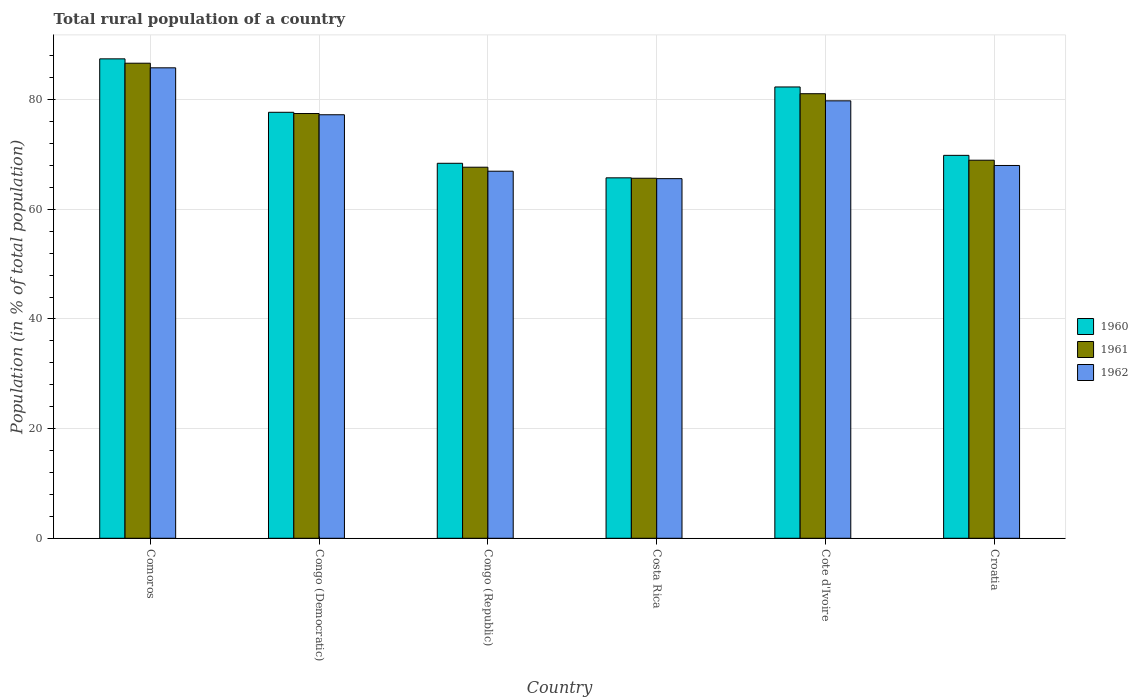How many groups of bars are there?
Offer a very short reply. 6. How many bars are there on the 5th tick from the right?
Provide a succinct answer. 3. What is the label of the 3rd group of bars from the left?
Your response must be concise. Congo (Republic). What is the rural population in 1960 in Costa Rica?
Provide a short and direct response. 65.75. Across all countries, what is the maximum rural population in 1961?
Keep it short and to the point. 86.65. Across all countries, what is the minimum rural population in 1961?
Your answer should be compact. 65.67. In which country was the rural population in 1962 maximum?
Your answer should be compact. Comoros. What is the total rural population in 1961 in the graph?
Keep it short and to the point. 447.53. What is the difference between the rural population in 1962 in Congo (Democratic) and that in Costa Rica?
Give a very brief answer. 11.66. What is the difference between the rural population in 1962 in Congo (Republic) and the rural population in 1961 in Cote d'Ivoire?
Ensure brevity in your answer.  -14.13. What is the average rural population in 1962 per country?
Offer a terse response. 73.9. What is the difference between the rural population of/in 1961 and rural population of/in 1960 in Comoros?
Your answer should be compact. -0.8. What is the ratio of the rural population in 1960 in Congo (Democratic) to that in Congo (Republic)?
Provide a succinct answer. 1.14. Is the rural population in 1961 in Congo (Republic) less than that in Croatia?
Provide a succinct answer. Yes. What is the difference between the highest and the second highest rural population in 1962?
Give a very brief answer. -8.56. What is the difference between the highest and the lowest rural population in 1960?
Your response must be concise. 21.7. Is the sum of the rural population in 1961 in Comoros and Croatia greater than the maximum rural population in 1962 across all countries?
Make the answer very short. Yes. What does the 1st bar from the left in Croatia represents?
Provide a succinct answer. 1960. What does the 2nd bar from the right in Congo (Republic) represents?
Your answer should be compact. 1961. Is it the case that in every country, the sum of the rural population in 1960 and rural population in 1962 is greater than the rural population in 1961?
Ensure brevity in your answer.  Yes. How many bars are there?
Your answer should be very brief. 18. Are all the bars in the graph horizontal?
Offer a terse response. No. How are the legend labels stacked?
Offer a terse response. Vertical. What is the title of the graph?
Give a very brief answer. Total rural population of a country. What is the label or title of the X-axis?
Your response must be concise. Country. What is the label or title of the Y-axis?
Ensure brevity in your answer.  Population (in % of total population). What is the Population (in % of total population) of 1960 in Comoros?
Your response must be concise. 87.45. What is the Population (in % of total population) of 1961 in Comoros?
Provide a short and direct response. 86.65. What is the Population (in % of total population) in 1962 in Comoros?
Your answer should be very brief. 85.81. What is the Population (in % of total population) in 1960 in Congo (Democratic)?
Make the answer very short. 77.7. What is the Population (in % of total population) in 1961 in Congo (Democratic)?
Provide a short and direct response. 77.48. What is the Population (in % of total population) of 1962 in Congo (Democratic)?
Offer a very short reply. 77.25. What is the Population (in % of total population) of 1960 in Congo (Republic)?
Make the answer very short. 68.4. What is the Population (in % of total population) in 1961 in Congo (Republic)?
Your answer should be compact. 67.68. What is the Population (in % of total population) of 1962 in Congo (Republic)?
Offer a terse response. 66.95. What is the Population (in % of total population) of 1960 in Costa Rica?
Offer a very short reply. 65.75. What is the Population (in % of total population) of 1961 in Costa Rica?
Your response must be concise. 65.67. What is the Population (in % of total population) of 1962 in Costa Rica?
Give a very brief answer. 65.6. What is the Population (in % of total population) in 1960 in Cote d'Ivoire?
Offer a very short reply. 82.32. What is the Population (in % of total population) in 1961 in Cote d'Ivoire?
Keep it short and to the point. 81.09. What is the Population (in % of total population) of 1962 in Cote d'Ivoire?
Your answer should be compact. 79.79. What is the Population (in % of total population) in 1960 in Croatia?
Ensure brevity in your answer.  69.85. What is the Population (in % of total population) in 1961 in Croatia?
Provide a short and direct response. 68.96. What is the Population (in % of total population) in 1962 in Croatia?
Your response must be concise. 68. Across all countries, what is the maximum Population (in % of total population) of 1960?
Ensure brevity in your answer.  87.45. Across all countries, what is the maximum Population (in % of total population) in 1961?
Offer a terse response. 86.65. Across all countries, what is the maximum Population (in % of total population) of 1962?
Keep it short and to the point. 85.81. Across all countries, what is the minimum Population (in % of total population) in 1960?
Provide a short and direct response. 65.75. Across all countries, what is the minimum Population (in % of total population) in 1961?
Provide a short and direct response. 65.67. Across all countries, what is the minimum Population (in % of total population) of 1962?
Offer a very short reply. 65.6. What is the total Population (in % of total population) of 1960 in the graph?
Provide a succinct answer. 451.46. What is the total Population (in % of total population) in 1961 in the graph?
Your answer should be very brief. 447.53. What is the total Population (in % of total population) of 1962 in the graph?
Provide a short and direct response. 443.4. What is the difference between the Population (in % of total population) of 1960 in Comoros and that in Congo (Democratic)?
Ensure brevity in your answer.  9.75. What is the difference between the Population (in % of total population) of 1961 in Comoros and that in Congo (Democratic)?
Your answer should be very brief. 9.18. What is the difference between the Population (in % of total population) of 1962 in Comoros and that in Congo (Democratic)?
Your answer should be very brief. 8.56. What is the difference between the Population (in % of total population) of 1960 in Comoros and that in Congo (Republic)?
Your answer should be compact. 19.05. What is the difference between the Population (in % of total population) in 1961 in Comoros and that in Congo (Republic)?
Offer a very short reply. 18.97. What is the difference between the Population (in % of total population) of 1962 in Comoros and that in Congo (Republic)?
Your answer should be compact. 18.86. What is the difference between the Population (in % of total population) of 1960 in Comoros and that in Costa Rica?
Give a very brief answer. 21.7. What is the difference between the Population (in % of total population) in 1961 in Comoros and that in Costa Rica?
Your answer should be very brief. 20.98. What is the difference between the Population (in % of total population) of 1962 in Comoros and that in Costa Rica?
Keep it short and to the point. 20.21. What is the difference between the Population (in % of total population) in 1960 in Comoros and that in Cote d'Ivoire?
Give a very brief answer. 5.13. What is the difference between the Population (in % of total population) of 1961 in Comoros and that in Cote d'Ivoire?
Keep it short and to the point. 5.56. What is the difference between the Population (in % of total population) of 1962 in Comoros and that in Cote d'Ivoire?
Give a very brief answer. 6.02. What is the difference between the Population (in % of total population) of 1960 in Comoros and that in Croatia?
Your answer should be very brief. 17.6. What is the difference between the Population (in % of total population) in 1961 in Comoros and that in Croatia?
Ensure brevity in your answer.  17.69. What is the difference between the Population (in % of total population) of 1962 in Comoros and that in Croatia?
Provide a short and direct response. 17.81. What is the difference between the Population (in % of total population) in 1960 in Congo (Democratic) and that in Congo (Republic)?
Your response must be concise. 9.3. What is the difference between the Population (in % of total population) in 1961 in Congo (Democratic) and that in Congo (Republic)?
Provide a succinct answer. 9.79. What is the difference between the Population (in % of total population) of 1962 in Congo (Democratic) and that in Congo (Republic)?
Your answer should be compact. 10.3. What is the difference between the Population (in % of total population) of 1960 in Congo (Democratic) and that in Costa Rica?
Keep it short and to the point. 11.95. What is the difference between the Population (in % of total population) in 1961 in Congo (Democratic) and that in Costa Rica?
Offer a very short reply. 11.81. What is the difference between the Population (in % of total population) of 1962 in Congo (Democratic) and that in Costa Rica?
Provide a short and direct response. 11.65. What is the difference between the Population (in % of total population) of 1960 in Congo (Democratic) and that in Cote d'Ivoire?
Make the answer very short. -4.62. What is the difference between the Population (in % of total population) of 1961 in Congo (Democratic) and that in Cote d'Ivoire?
Your answer should be very brief. -3.61. What is the difference between the Population (in % of total population) of 1962 in Congo (Democratic) and that in Cote d'Ivoire?
Provide a succinct answer. -2.54. What is the difference between the Population (in % of total population) of 1960 in Congo (Democratic) and that in Croatia?
Provide a short and direct response. 7.85. What is the difference between the Population (in % of total population) of 1961 in Congo (Democratic) and that in Croatia?
Provide a short and direct response. 8.52. What is the difference between the Population (in % of total population) of 1962 in Congo (Democratic) and that in Croatia?
Your response must be concise. 9.25. What is the difference between the Population (in % of total population) in 1960 in Congo (Republic) and that in Costa Rica?
Your answer should be very brief. 2.65. What is the difference between the Population (in % of total population) in 1961 in Congo (Republic) and that in Costa Rica?
Offer a very short reply. 2.01. What is the difference between the Population (in % of total population) in 1962 in Congo (Republic) and that in Costa Rica?
Keep it short and to the point. 1.36. What is the difference between the Population (in % of total population) of 1960 in Congo (Republic) and that in Cote d'Ivoire?
Keep it short and to the point. -13.92. What is the difference between the Population (in % of total population) of 1961 in Congo (Republic) and that in Cote d'Ivoire?
Keep it short and to the point. -13.41. What is the difference between the Population (in % of total population) in 1962 in Congo (Republic) and that in Cote d'Ivoire?
Keep it short and to the point. -12.84. What is the difference between the Population (in % of total population) of 1960 in Congo (Republic) and that in Croatia?
Ensure brevity in your answer.  -1.45. What is the difference between the Population (in % of total population) of 1961 in Congo (Republic) and that in Croatia?
Your answer should be compact. -1.28. What is the difference between the Population (in % of total population) of 1962 in Congo (Republic) and that in Croatia?
Your answer should be compact. -1.04. What is the difference between the Population (in % of total population) of 1960 in Costa Rica and that in Cote d'Ivoire?
Keep it short and to the point. -16.57. What is the difference between the Population (in % of total population) of 1961 in Costa Rica and that in Cote d'Ivoire?
Keep it short and to the point. -15.42. What is the difference between the Population (in % of total population) of 1962 in Costa Rica and that in Cote d'Ivoire?
Offer a terse response. -14.19. What is the difference between the Population (in % of total population) of 1961 in Costa Rica and that in Croatia?
Offer a very short reply. -3.29. What is the difference between the Population (in % of total population) in 1962 in Costa Rica and that in Croatia?
Offer a terse response. -2.4. What is the difference between the Population (in % of total population) in 1960 in Cote d'Ivoire and that in Croatia?
Offer a terse response. 12.47. What is the difference between the Population (in % of total population) in 1961 in Cote d'Ivoire and that in Croatia?
Your response must be concise. 12.13. What is the difference between the Population (in % of total population) in 1962 in Cote d'Ivoire and that in Croatia?
Ensure brevity in your answer.  11.79. What is the difference between the Population (in % of total population) of 1960 in Comoros and the Population (in % of total population) of 1961 in Congo (Democratic)?
Keep it short and to the point. 9.97. What is the difference between the Population (in % of total population) of 1960 in Comoros and the Population (in % of total population) of 1962 in Congo (Democratic)?
Your answer should be compact. 10.2. What is the difference between the Population (in % of total population) of 1961 in Comoros and the Population (in % of total population) of 1962 in Congo (Democratic)?
Your answer should be very brief. 9.4. What is the difference between the Population (in % of total population) in 1960 in Comoros and the Population (in % of total population) in 1961 in Congo (Republic)?
Keep it short and to the point. 19.77. What is the difference between the Population (in % of total population) in 1960 in Comoros and the Population (in % of total population) in 1962 in Congo (Republic)?
Provide a short and direct response. 20.49. What is the difference between the Population (in % of total population) of 1961 in Comoros and the Population (in % of total population) of 1962 in Congo (Republic)?
Your answer should be compact. 19.7. What is the difference between the Population (in % of total population) in 1960 in Comoros and the Population (in % of total population) in 1961 in Costa Rica?
Make the answer very short. 21.78. What is the difference between the Population (in % of total population) of 1960 in Comoros and the Population (in % of total population) of 1962 in Costa Rica?
Make the answer very short. 21.85. What is the difference between the Population (in % of total population) in 1961 in Comoros and the Population (in % of total population) in 1962 in Costa Rica?
Make the answer very short. 21.06. What is the difference between the Population (in % of total population) in 1960 in Comoros and the Population (in % of total population) in 1961 in Cote d'Ivoire?
Make the answer very short. 6.36. What is the difference between the Population (in % of total population) of 1960 in Comoros and the Population (in % of total population) of 1962 in Cote d'Ivoire?
Your response must be concise. 7.66. What is the difference between the Population (in % of total population) in 1961 in Comoros and the Population (in % of total population) in 1962 in Cote d'Ivoire?
Make the answer very short. 6.86. What is the difference between the Population (in % of total population) of 1960 in Comoros and the Population (in % of total population) of 1961 in Croatia?
Give a very brief answer. 18.49. What is the difference between the Population (in % of total population) in 1960 in Comoros and the Population (in % of total population) in 1962 in Croatia?
Give a very brief answer. 19.45. What is the difference between the Population (in % of total population) in 1961 in Comoros and the Population (in % of total population) in 1962 in Croatia?
Give a very brief answer. 18.65. What is the difference between the Population (in % of total population) in 1960 in Congo (Democratic) and the Population (in % of total population) in 1961 in Congo (Republic)?
Provide a short and direct response. 10.02. What is the difference between the Population (in % of total population) of 1960 in Congo (Democratic) and the Population (in % of total population) of 1962 in Congo (Republic)?
Your answer should be very brief. 10.74. What is the difference between the Population (in % of total population) of 1961 in Congo (Democratic) and the Population (in % of total population) of 1962 in Congo (Republic)?
Offer a terse response. 10.52. What is the difference between the Population (in % of total population) in 1960 in Congo (Democratic) and the Population (in % of total population) in 1961 in Costa Rica?
Provide a succinct answer. 12.03. What is the difference between the Population (in % of total population) of 1960 in Congo (Democratic) and the Population (in % of total population) of 1962 in Costa Rica?
Your response must be concise. 12.1. What is the difference between the Population (in % of total population) in 1961 in Congo (Democratic) and the Population (in % of total population) in 1962 in Costa Rica?
Your answer should be compact. 11.88. What is the difference between the Population (in % of total population) of 1960 in Congo (Democratic) and the Population (in % of total population) of 1961 in Cote d'Ivoire?
Provide a succinct answer. -3.39. What is the difference between the Population (in % of total population) of 1960 in Congo (Democratic) and the Population (in % of total population) of 1962 in Cote d'Ivoire?
Ensure brevity in your answer.  -2.09. What is the difference between the Population (in % of total population) in 1961 in Congo (Democratic) and the Population (in % of total population) in 1962 in Cote d'Ivoire?
Your response must be concise. -2.31. What is the difference between the Population (in % of total population) in 1960 in Congo (Democratic) and the Population (in % of total population) in 1961 in Croatia?
Provide a succinct answer. 8.74. What is the difference between the Population (in % of total population) of 1960 in Congo (Democratic) and the Population (in % of total population) of 1962 in Croatia?
Offer a very short reply. 9.7. What is the difference between the Population (in % of total population) in 1961 in Congo (Democratic) and the Population (in % of total population) in 1962 in Croatia?
Offer a very short reply. 9.48. What is the difference between the Population (in % of total population) of 1960 in Congo (Republic) and the Population (in % of total population) of 1961 in Costa Rica?
Make the answer very short. 2.73. What is the difference between the Population (in % of total population) of 1960 in Congo (Republic) and the Population (in % of total population) of 1962 in Costa Rica?
Your response must be concise. 2.8. What is the difference between the Population (in % of total population) of 1961 in Congo (Republic) and the Population (in % of total population) of 1962 in Costa Rica?
Offer a very short reply. 2.09. What is the difference between the Population (in % of total population) in 1960 in Congo (Republic) and the Population (in % of total population) in 1961 in Cote d'Ivoire?
Give a very brief answer. -12.69. What is the difference between the Population (in % of total population) in 1960 in Congo (Republic) and the Population (in % of total population) in 1962 in Cote d'Ivoire?
Provide a succinct answer. -11.39. What is the difference between the Population (in % of total population) in 1961 in Congo (Republic) and the Population (in % of total population) in 1962 in Cote d'Ivoire?
Your answer should be very brief. -12.11. What is the difference between the Population (in % of total population) in 1960 in Congo (Republic) and the Population (in % of total population) in 1961 in Croatia?
Give a very brief answer. -0.56. What is the difference between the Population (in % of total population) of 1961 in Congo (Republic) and the Population (in % of total population) of 1962 in Croatia?
Ensure brevity in your answer.  -0.32. What is the difference between the Population (in % of total population) in 1960 in Costa Rica and the Population (in % of total population) in 1961 in Cote d'Ivoire?
Offer a very short reply. -15.34. What is the difference between the Population (in % of total population) in 1960 in Costa Rica and the Population (in % of total population) in 1962 in Cote d'Ivoire?
Your answer should be compact. -14.04. What is the difference between the Population (in % of total population) of 1961 in Costa Rica and the Population (in % of total population) of 1962 in Cote d'Ivoire?
Your response must be concise. -14.12. What is the difference between the Population (in % of total population) in 1960 in Costa Rica and the Population (in % of total population) in 1961 in Croatia?
Your answer should be very brief. -3.21. What is the difference between the Population (in % of total population) in 1960 in Costa Rica and the Population (in % of total population) in 1962 in Croatia?
Your answer should be very brief. -2.25. What is the difference between the Population (in % of total population) in 1961 in Costa Rica and the Population (in % of total population) in 1962 in Croatia?
Your answer should be very brief. -2.33. What is the difference between the Population (in % of total population) of 1960 in Cote d'Ivoire and the Population (in % of total population) of 1961 in Croatia?
Make the answer very short. 13.36. What is the difference between the Population (in % of total population) in 1960 in Cote d'Ivoire and the Population (in % of total population) in 1962 in Croatia?
Give a very brief answer. 14.32. What is the difference between the Population (in % of total population) in 1961 in Cote d'Ivoire and the Population (in % of total population) in 1962 in Croatia?
Ensure brevity in your answer.  13.09. What is the average Population (in % of total population) in 1960 per country?
Offer a terse response. 75.24. What is the average Population (in % of total population) of 1961 per country?
Offer a very short reply. 74.59. What is the average Population (in % of total population) in 1962 per country?
Your answer should be very brief. 73.9. What is the difference between the Population (in % of total population) of 1960 and Population (in % of total population) of 1961 in Comoros?
Give a very brief answer. 0.8. What is the difference between the Population (in % of total population) in 1960 and Population (in % of total population) in 1962 in Comoros?
Provide a short and direct response. 1.64. What is the difference between the Population (in % of total population) of 1961 and Population (in % of total population) of 1962 in Comoros?
Your response must be concise. 0.84. What is the difference between the Population (in % of total population) of 1960 and Population (in % of total population) of 1961 in Congo (Democratic)?
Your answer should be very brief. 0.22. What is the difference between the Population (in % of total population) of 1960 and Population (in % of total population) of 1962 in Congo (Democratic)?
Offer a terse response. 0.45. What is the difference between the Population (in % of total population) of 1961 and Population (in % of total population) of 1962 in Congo (Democratic)?
Provide a succinct answer. 0.23. What is the difference between the Population (in % of total population) of 1960 and Population (in % of total population) of 1961 in Congo (Republic)?
Your response must be concise. 0.72. What is the difference between the Population (in % of total population) of 1960 and Population (in % of total population) of 1962 in Congo (Republic)?
Offer a terse response. 1.44. What is the difference between the Population (in % of total population) in 1961 and Population (in % of total population) in 1962 in Congo (Republic)?
Your answer should be very brief. 0.73. What is the difference between the Population (in % of total population) in 1960 and Population (in % of total population) in 1961 in Costa Rica?
Your answer should be very brief. 0.07. What is the difference between the Population (in % of total population) of 1960 and Population (in % of total population) of 1962 in Costa Rica?
Offer a very short reply. 0.15. What is the difference between the Population (in % of total population) in 1961 and Population (in % of total population) in 1962 in Costa Rica?
Ensure brevity in your answer.  0.07. What is the difference between the Population (in % of total population) in 1960 and Population (in % of total population) in 1961 in Cote d'Ivoire?
Offer a terse response. 1.23. What is the difference between the Population (in % of total population) of 1960 and Population (in % of total population) of 1962 in Cote d'Ivoire?
Make the answer very short. 2.53. What is the difference between the Population (in % of total population) in 1961 and Population (in % of total population) in 1962 in Cote d'Ivoire?
Your answer should be compact. 1.3. What is the difference between the Population (in % of total population) of 1960 and Population (in % of total population) of 1961 in Croatia?
Offer a terse response. 0.89. What is the difference between the Population (in % of total population) in 1960 and Population (in % of total population) in 1962 in Croatia?
Offer a very short reply. 1.85. What is the ratio of the Population (in % of total population) of 1960 in Comoros to that in Congo (Democratic)?
Ensure brevity in your answer.  1.13. What is the ratio of the Population (in % of total population) of 1961 in Comoros to that in Congo (Democratic)?
Offer a terse response. 1.12. What is the ratio of the Population (in % of total population) in 1962 in Comoros to that in Congo (Democratic)?
Your answer should be compact. 1.11. What is the ratio of the Population (in % of total population) of 1960 in Comoros to that in Congo (Republic)?
Provide a short and direct response. 1.28. What is the ratio of the Population (in % of total population) of 1961 in Comoros to that in Congo (Republic)?
Your answer should be very brief. 1.28. What is the ratio of the Population (in % of total population) of 1962 in Comoros to that in Congo (Republic)?
Offer a terse response. 1.28. What is the ratio of the Population (in % of total population) in 1960 in Comoros to that in Costa Rica?
Your answer should be very brief. 1.33. What is the ratio of the Population (in % of total population) in 1961 in Comoros to that in Costa Rica?
Your response must be concise. 1.32. What is the ratio of the Population (in % of total population) of 1962 in Comoros to that in Costa Rica?
Ensure brevity in your answer.  1.31. What is the ratio of the Population (in % of total population) in 1960 in Comoros to that in Cote d'Ivoire?
Offer a very short reply. 1.06. What is the ratio of the Population (in % of total population) in 1961 in Comoros to that in Cote d'Ivoire?
Your answer should be compact. 1.07. What is the ratio of the Population (in % of total population) of 1962 in Comoros to that in Cote d'Ivoire?
Offer a terse response. 1.08. What is the ratio of the Population (in % of total population) in 1960 in Comoros to that in Croatia?
Your answer should be compact. 1.25. What is the ratio of the Population (in % of total population) of 1961 in Comoros to that in Croatia?
Provide a short and direct response. 1.26. What is the ratio of the Population (in % of total population) in 1962 in Comoros to that in Croatia?
Your answer should be very brief. 1.26. What is the ratio of the Population (in % of total population) in 1960 in Congo (Democratic) to that in Congo (Republic)?
Ensure brevity in your answer.  1.14. What is the ratio of the Population (in % of total population) of 1961 in Congo (Democratic) to that in Congo (Republic)?
Provide a succinct answer. 1.14. What is the ratio of the Population (in % of total population) of 1962 in Congo (Democratic) to that in Congo (Republic)?
Ensure brevity in your answer.  1.15. What is the ratio of the Population (in % of total population) of 1960 in Congo (Democratic) to that in Costa Rica?
Offer a terse response. 1.18. What is the ratio of the Population (in % of total population) in 1961 in Congo (Democratic) to that in Costa Rica?
Your answer should be very brief. 1.18. What is the ratio of the Population (in % of total population) of 1962 in Congo (Democratic) to that in Costa Rica?
Provide a short and direct response. 1.18. What is the ratio of the Population (in % of total population) in 1960 in Congo (Democratic) to that in Cote d'Ivoire?
Provide a short and direct response. 0.94. What is the ratio of the Population (in % of total population) of 1961 in Congo (Democratic) to that in Cote d'Ivoire?
Offer a terse response. 0.96. What is the ratio of the Population (in % of total population) of 1962 in Congo (Democratic) to that in Cote d'Ivoire?
Keep it short and to the point. 0.97. What is the ratio of the Population (in % of total population) in 1960 in Congo (Democratic) to that in Croatia?
Provide a succinct answer. 1.11. What is the ratio of the Population (in % of total population) in 1961 in Congo (Democratic) to that in Croatia?
Give a very brief answer. 1.12. What is the ratio of the Population (in % of total population) of 1962 in Congo (Democratic) to that in Croatia?
Make the answer very short. 1.14. What is the ratio of the Population (in % of total population) of 1960 in Congo (Republic) to that in Costa Rica?
Offer a terse response. 1.04. What is the ratio of the Population (in % of total population) in 1961 in Congo (Republic) to that in Costa Rica?
Offer a terse response. 1.03. What is the ratio of the Population (in % of total population) in 1962 in Congo (Republic) to that in Costa Rica?
Your response must be concise. 1.02. What is the ratio of the Population (in % of total population) of 1960 in Congo (Republic) to that in Cote d'Ivoire?
Make the answer very short. 0.83. What is the ratio of the Population (in % of total population) of 1961 in Congo (Republic) to that in Cote d'Ivoire?
Make the answer very short. 0.83. What is the ratio of the Population (in % of total population) in 1962 in Congo (Republic) to that in Cote d'Ivoire?
Ensure brevity in your answer.  0.84. What is the ratio of the Population (in % of total population) in 1960 in Congo (Republic) to that in Croatia?
Give a very brief answer. 0.98. What is the ratio of the Population (in % of total population) of 1961 in Congo (Republic) to that in Croatia?
Your response must be concise. 0.98. What is the ratio of the Population (in % of total population) of 1962 in Congo (Republic) to that in Croatia?
Make the answer very short. 0.98. What is the ratio of the Population (in % of total population) of 1960 in Costa Rica to that in Cote d'Ivoire?
Provide a short and direct response. 0.8. What is the ratio of the Population (in % of total population) of 1961 in Costa Rica to that in Cote d'Ivoire?
Make the answer very short. 0.81. What is the ratio of the Population (in % of total population) in 1962 in Costa Rica to that in Cote d'Ivoire?
Your answer should be very brief. 0.82. What is the ratio of the Population (in % of total population) in 1960 in Costa Rica to that in Croatia?
Your answer should be compact. 0.94. What is the ratio of the Population (in % of total population) of 1961 in Costa Rica to that in Croatia?
Your response must be concise. 0.95. What is the ratio of the Population (in % of total population) in 1962 in Costa Rica to that in Croatia?
Make the answer very short. 0.96. What is the ratio of the Population (in % of total population) in 1960 in Cote d'Ivoire to that in Croatia?
Keep it short and to the point. 1.18. What is the ratio of the Population (in % of total population) of 1961 in Cote d'Ivoire to that in Croatia?
Your answer should be very brief. 1.18. What is the ratio of the Population (in % of total population) of 1962 in Cote d'Ivoire to that in Croatia?
Offer a terse response. 1.17. What is the difference between the highest and the second highest Population (in % of total population) in 1960?
Provide a succinct answer. 5.13. What is the difference between the highest and the second highest Population (in % of total population) of 1961?
Provide a short and direct response. 5.56. What is the difference between the highest and the second highest Population (in % of total population) of 1962?
Make the answer very short. 6.02. What is the difference between the highest and the lowest Population (in % of total population) of 1960?
Provide a short and direct response. 21.7. What is the difference between the highest and the lowest Population (in % of total population) of 1961?
Your response must be concise. 20.98. What is the difference between the highest and the lowest Population (in % of total population) in 1962?
Provide a short and direct response. 20.21. 